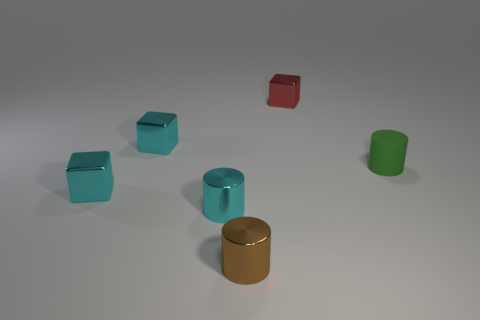Add 3 tiny metal cylinders. How many objects exist? 9 Subtract all small yellow matte things. Subtract all tiny cylinders. How many objects are left? 3 Add 6 rubber objects. How many rubber objects are left? 7 Add 2 small green rubber cylinders. How many small green rubber cylinders exist? 3 Subtract 0 yellow cubes. How many objects are left? 6 